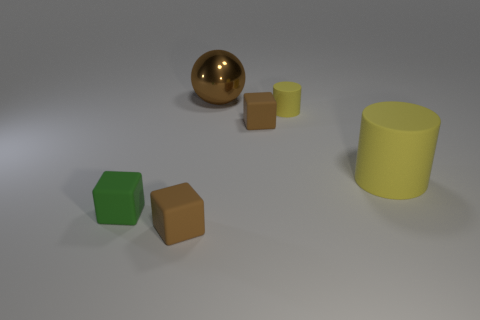Can you talk about the textures and materials of the objects? Certainly! The two cubes appear to have a matte finish with a single color each, green and brown. The small and large cylinders have a smooth surface with a plain light yellow color. In contrast, the sphere has a reflective golden surface that stands out against the other objects. 